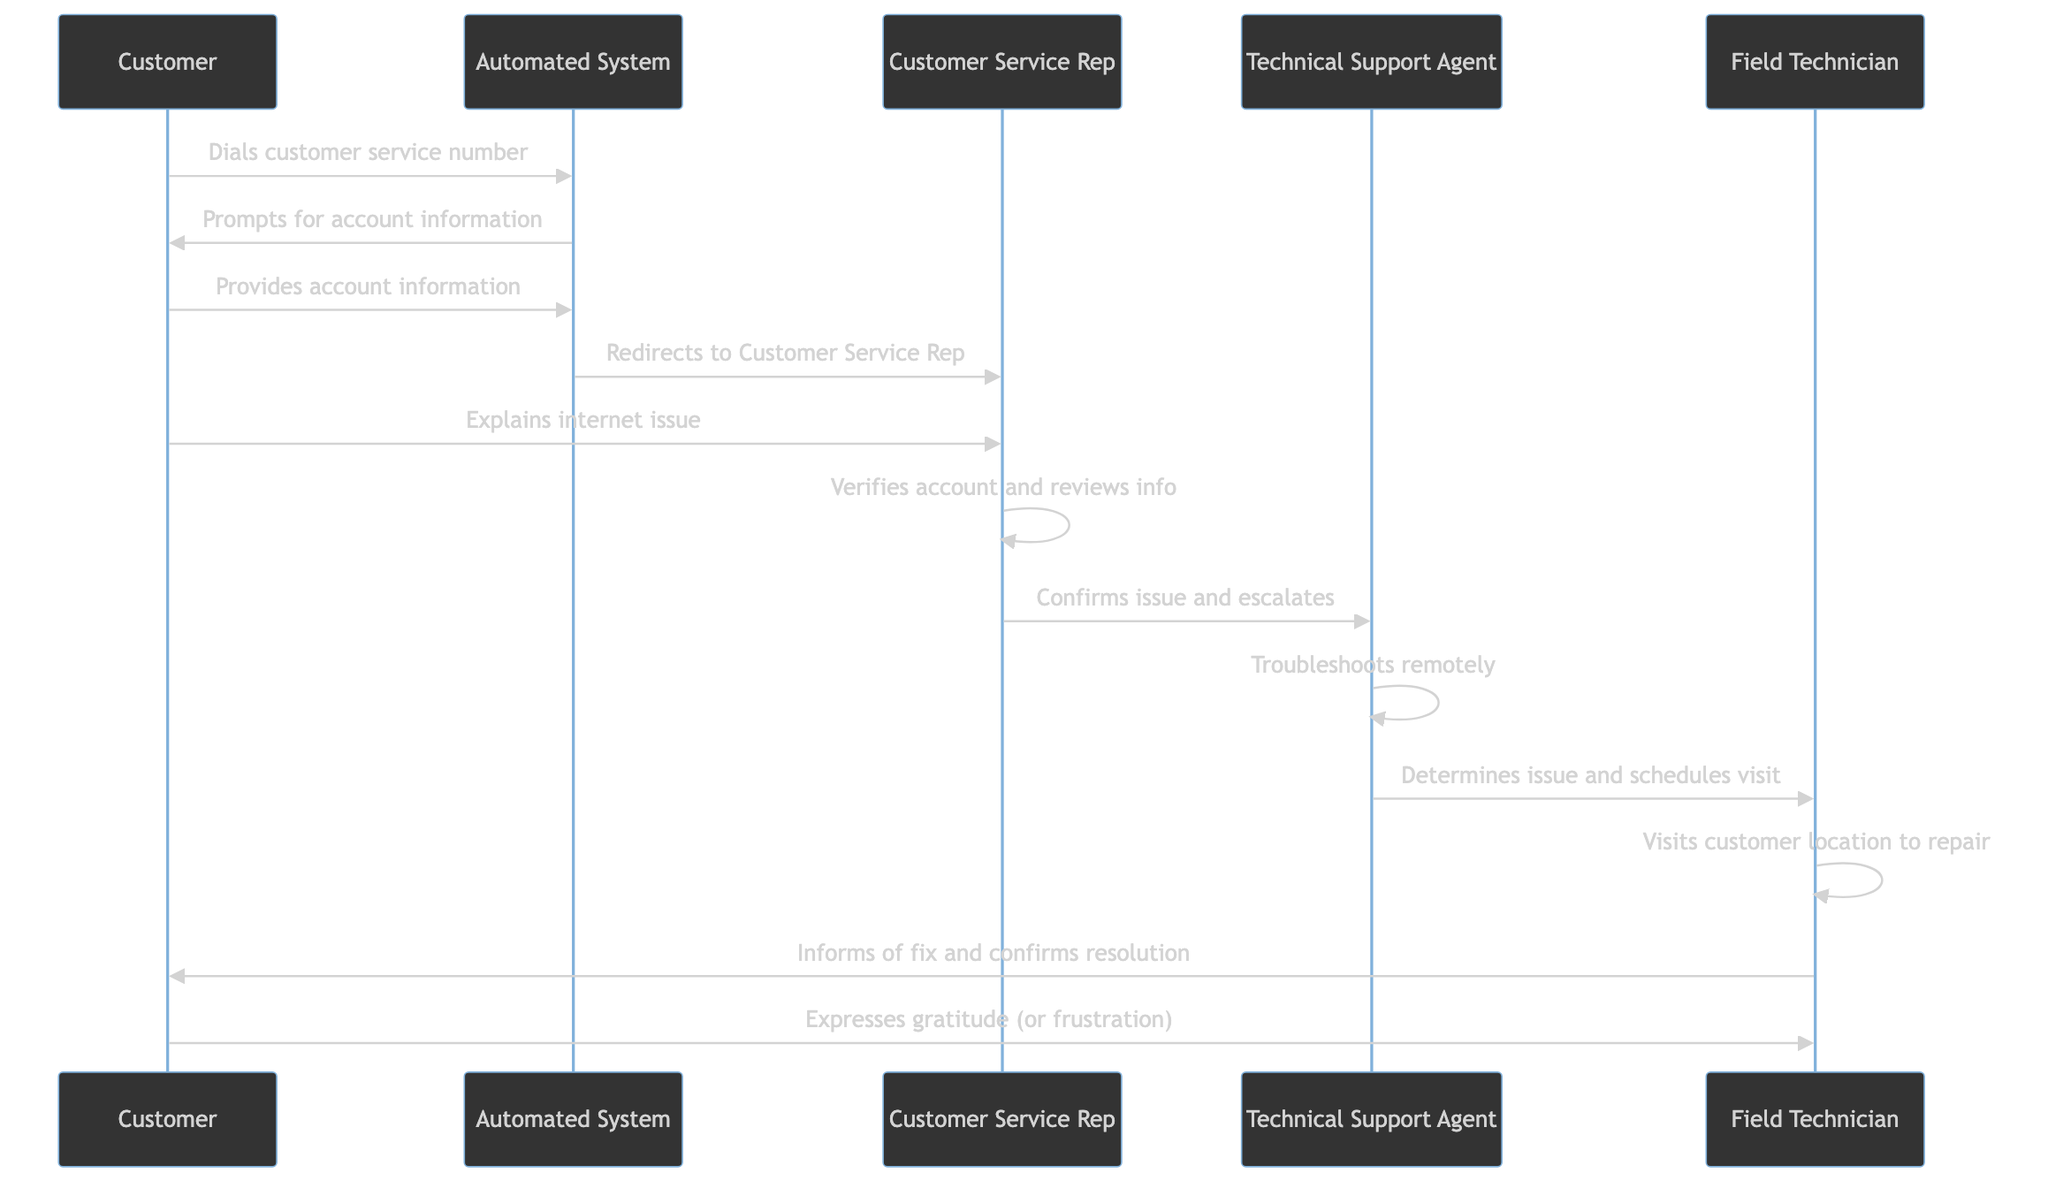What's the first action in the sequence? The first action indicated is the "Customer dials customer service number," which is the first interaction in the flow of the diagram.
Answer: Customer dials customer service number Who does the Automated System redirect to? The Automated System redirects to the "Customer Service Rep" after the customer provides their account information, as shown in the corresponding interaction step in the diagram.
Answer: Customer Service Rep What is the role of the Technical Support Agent in this process? The Technical Support Agent is responsible for troubleshooting the customer's issue remotely and determining if a field visit is needed, as indicated by the actions assigned to this role in the sequence.
Answer: Troubleshoots remotely How many actors are involved in the call navigation process? There are 5 actors involved: Customer, Automated System, Customer Service Rep, Technical Support Agent, and Field Technician, as counted from the list of participants in the diagram.
Answer: 5 What does the Field Technician do after visiting the customer's location? After visiting the customer's location, the Field Technician informs the customer of the fix and confirms the resolution of the internet issue, which is indicated as the final action associated with this actor.
Answer: Informs of fix and confirms resolution Which actor is responsible for verifying the customer's account? The Customer Service Rep is responsible for verifying the account and reviewing the customer information before escalating the issue, as shown in the diagram.
Answer: Customer Service Rep What problem does the customer explain to the Customer Service Rep? The customer explains their "internet issue," which is the subject matter of the interaction between the customer and the Customer Service Rep as depicted in the sequence.
Answer: Internet issue List the sequence of actions starting with the Customer dialing the number. The sequence begins with the Customer dialing the customer service number, then the Automated System prompts for account information, the Customer provides the account information, redirects to the Customer Service Rep, and so forth, following the flow indicated in the diagram.
Answer: Dials customer service number, prompts for account information, provides account information, redirects to Customer Service Rep, explains internet issue 